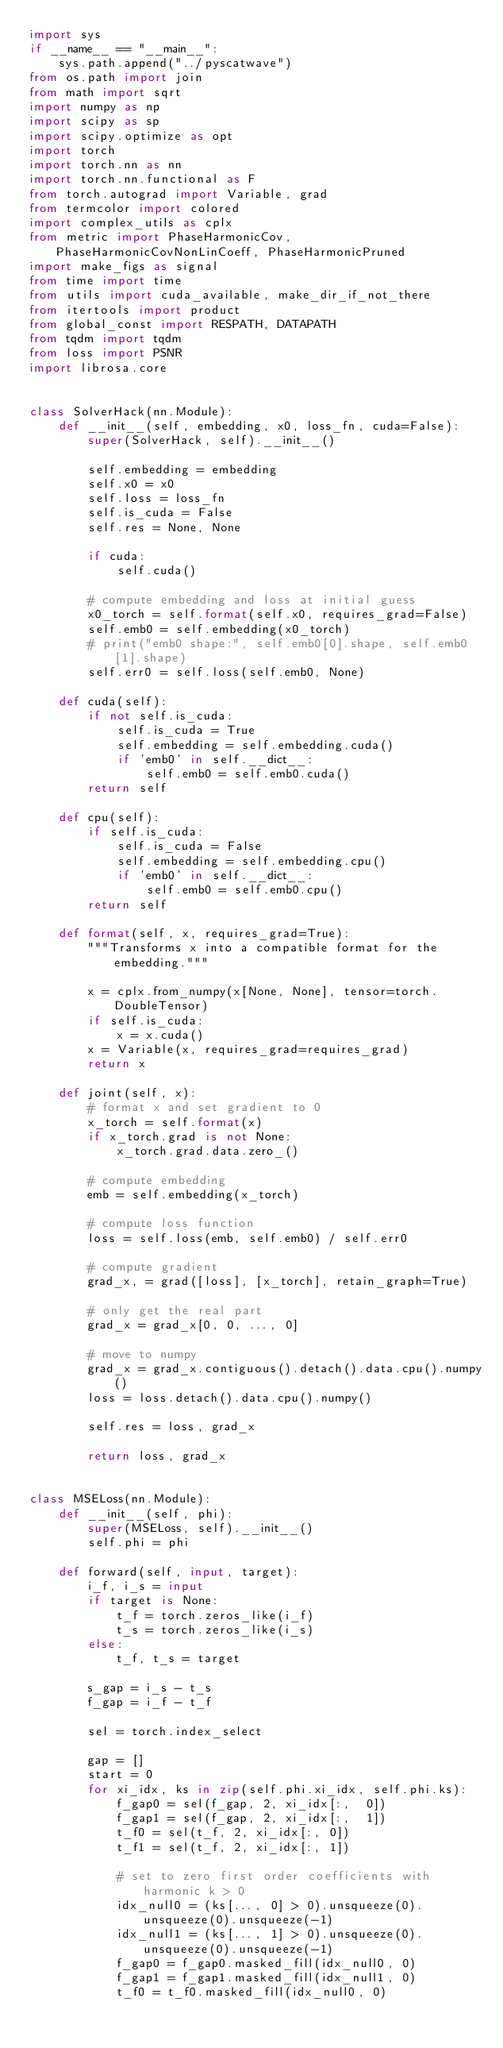<code> <loc_0><loc_0><loc_500><loc_500><_Python_>import sys
if __name__ == "__main__":
    sys.path.append("../pyscatwave")
from os.path import join
from math import sqrt
import numpy as np
import scipy as sp
import scipy.optimize as opt
import torch
import torch.nn as nn
import torch.nn.functional as F
from torch.autograd import Variable, grad
from termcolor import colored
import complex_utils as cplx
from metric import PhaseHarmonicCov, PhaseHarmonicCovNonLinCoeff, PhaseHarmonicPruned
import make_figs as signal
from time import time
from utils import cuda_available, make_dir_if_not_there
from itertools import product
from global_const import RESPATH, DATAPATH
from tqdm import tqdm
from loss import PSNR
import librosa.core


class SolverHack(nn.Module):
    def __init__(self, embedding, x0, loss_fn, cuda=False):
        super(SolverHack, self).__init__()

        self.embedding = embedding
        self.x0 = x0
        self.loss = loss_fn
        self.is_cuda = False
        self.res = None, None

        if cuda:
            self.cuda()

        # compute embedding and loss at initial guess
        x0_torch = self.format(self.x0, requires_grad=False)
        self.emb0 = self.embedding(x0_torch)
        # print("emb0 shape:", self.emb0[0].shape, self.emb0[1].shape)
        self.err0 = self.loss(self.emb0, None)

    def cuda(self):
        if not self.is_cuda:
            self.is_cuda = True
            self.embedding = self.embedding.cuda()
            if 'emb0' in self.__dict__:
                self.emb0 = self.emb0.cuda()
        return self

    def cpu(self):
        if self.is_cuda:
            self.is_cuda = False
            self.embedding = self.embedding.cpu()
            if 'emb0' in self.__dict__:
                self.emb0 = self.emb0.cpu()
        return self

    def format(self, x, requires_grad=True):
        """Transforms x into a compatible format for the embedding."""

        x = cplx.from_numpy(x[None, None], tensor=torch.DoubleTensor)
        if self.is_cuda:
            x = x.cuda()
        x = Variable(x, requires_grad=requires_grad)
        return x

    def joint(self, x):
        # format x and set gradient to 0
        x_torch = self.format(x)
        if x_torch.grad is not None:
            x_torch.grad.data.zero_()

        # compute embedding
        emb = self.embedding(x_torch)

        # compute loss function
        loss = self.loss(emb, self.emb0) / self.err0

        # compute gradient
        grad_x, = grad([loss], [x_torch], retain_graph=True)

        # only get the real part
        grad_x = grad_x[0, 0, ..., 0]

        # move to numpy
        grad_x = grad_x.contiguous().detach().data.cpu().numpy()
        loss = loss.detach().data.cpu().numpy()

        self.res = loss, grad_x

        return loss, grad_x


class MSELoss(nn.Module):
    def __init__(self, phi):
        super(MSELoss, self).__init__()
        self.phi = phi

    def forward(self, input, target):
        i_f, i_s = input
        if target is None:
            t_f = torch.zeros_like(i_f)
            t_s = torch.zeros_like(i_s)
        else:
            t_f, t_s = target

        s_gap = i_s - t_s
        f_gap = i_f - t_f

        sel = torch.index_select

        gap = []
        start = 0
        for xi_idx, ks in zip(self.phi.xi_idx, self.phi.ks):
            f_gap0 = sel(f_gap, 2, xi_idx[:,  0])
            f_gap1 = sel(f_gap, 2, xi_idx[:,  1])
            t_f0 = sel(t_f, 2, xi_idx[:, 0])
            t_f1 = sel(t_f, 2, xi_idx[:, 1])

            # set to zero first order coefficients with harmonic k > 0
            idx_null0 = (ks[..., 0] > 0).unsqueeze(0).unsqueeze(0).unsqueeze(-1)
            idx_null1 = (ks[..., 1] > 0).unsqueeze(0).unsqueeze(0).unsqueeze(-1)
            f_gap0 = f_gap0.masked_fill(idx_null0, 0)
            f_gap1 = f_gap1.masked_fill(idx_null1, 0)
            t_f0 = t_f0.masked_fill(idx_null0, 0)</code> 